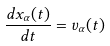Convert formula to latex. <formula><loc_0><loc_0><loc_500><loc_500>\frac { d x _ { \alpha } ( t ) } { d t } = v _ { \alpha } ( t )</formula> 